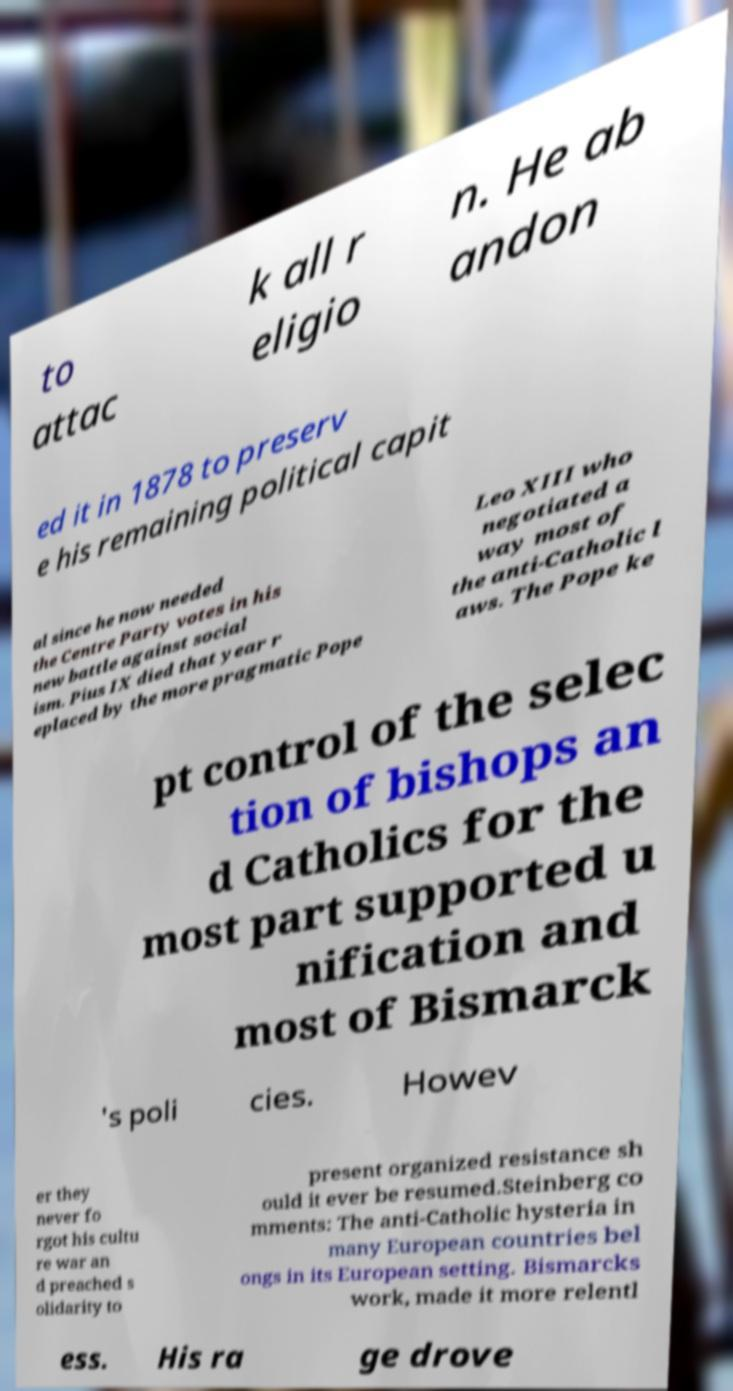Could you assist in decoding the text presented in this image and type it out clearly? to attac k all r eligio n. He ab andon ed it in 1878 to preserv e his remaining political capit al since he now needed the Centre Party votes in his new battle against social ism. Pius IX died that year r eplaced by the more pragmatic Pope Leo XIII who negotiated a way most of the anti-Catholic l aws. The Pope ke pt control of the selec tion of bishops an d Catholics for the most part supported u nification and most of Bismarck 's poli cies. Howev er they never fo rgot his cultu re war an d preached s olidarity to present organized resistance sh ould it ever be resumed.Steinberg co mments: The anti-Catholic hysteria in many European countries bel ongs in its European setting. Bismarcks work, made it more relentl ess. His ra ge drove 